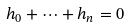Convert formula to latex. <formula><loc_0><loc_0><loc_500><loc_500>h _ { 0 } + \cdots + h _ { n } = 0</formula> 